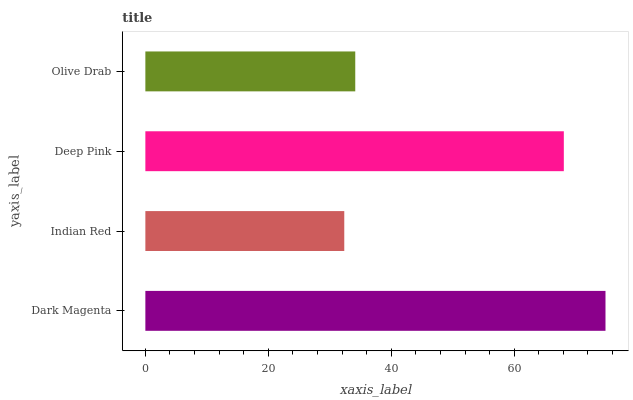Is Indian Red the minimum?
Answer yes or no. Yes. Is Dark Magenta the maximum?
Answer yes or no. Yes. Is Deep Pink the minimum?
Answer yes or no. No. Is Deep Pink the maximum?
Answer yes or no. No. Is Deep Pink greater than Indian Red?
Answer yes or no. Yes. Is Indian Red less than Deep Pink?
Answer yes or no. Yes. Is Indian Red greater than Deep Pink?
Answer yes or no. No. Is Deep Pink less than Indian Red?
Answer yes or no. No. Is Deep Pink the high median?
Answer yes or no. Yes. Is Olive Drab the low median?
Answer yes or no. Yes. Is Olive Drab the high median?
Answer yes or no. No. Is Dark Magenta the low median?
Answer yes or no. No. 